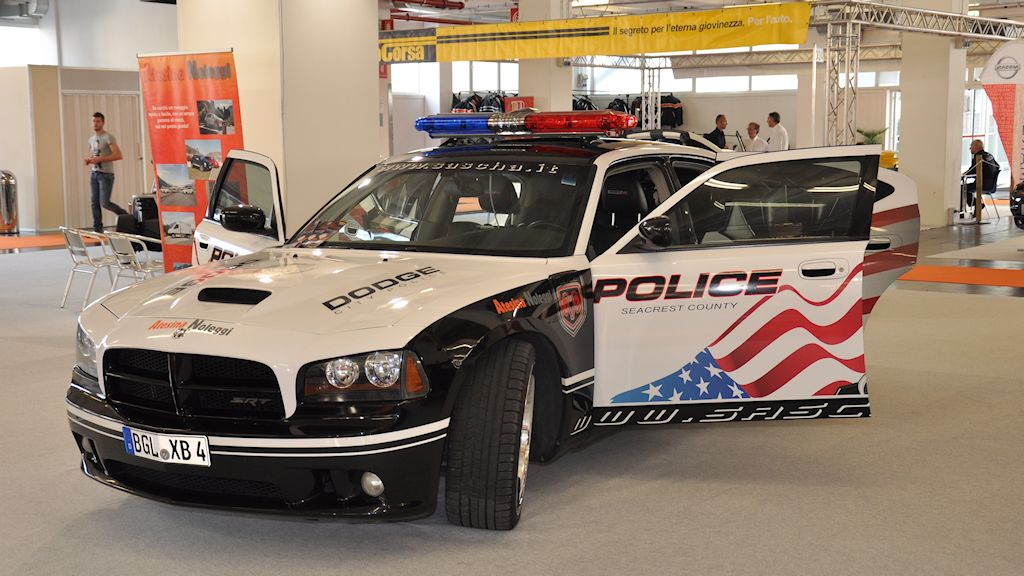Describe a day in the life of an officer driving this vehicle on duty. A day in the life of an officer driving this vehicle starts early with a briefing at the station, where the officer is updated on the day's assignments. Once on the road, they conduct routine patrols, leveraging the vehicle's high visibility to deter crime and engage with community members. Throughout the day, the officer responds to various calls, ranging from traffic stops to emergency situations, where the vehicle's advanced communication and navigation systems prove invaluable. During breaks, they participate in community outreach events, showcasing the vehicle and discussing public safety initiatives with residents. Even off-duty, at events or exhibitions, the vehicle serves as a symbol of law enforcement's commitment to the community. 